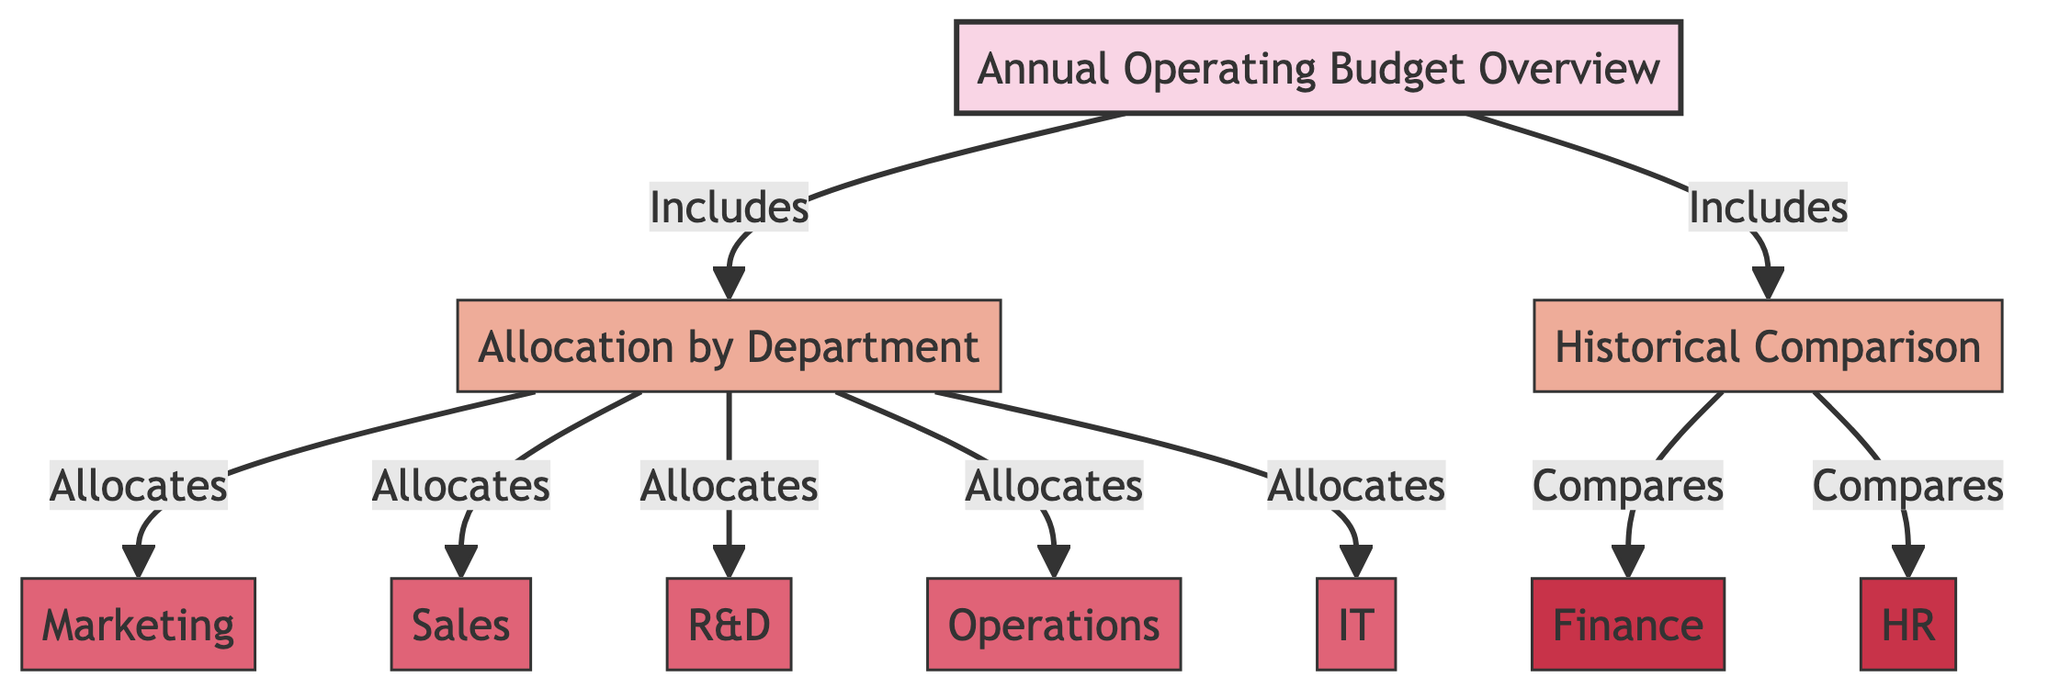What does the "Annual Operating Budget Overview" include? The diagram indicates that the "Annual Operating Budget Overview" includes two main components: "Allocation by Department" and "Historical Comparison." This information is directly connected to the central node, showing the inclusivity of these two categories.
Answer: Allocation by Department, Historical Comparison How many departments are allocated within the "Allocation by Department"? The diagram identifies five departments that receive allocations, which are "Marketing," "Sales," "R&D," "Operations," and "IT." Each department is represented as a separate node branching from the "Allocation by Department" node.
Answer: Five Which comparison is associated with "Finance"? The node "Finance Comparison" is explicitly linked to the "Historical Comparison" section of the diagram, indicating that it is the comparison related to finance.
Answer: Finance What is the relationship between "Historical Comparison" and "HR"? The diagram shows that "HR Comparison" is directly connected to the "Historical Comparison," illustrating a comparative relationship. This signifies that HR performance is assessed in regard to historical data.
Answer: Compares Which category does "Operations" belong to? The node "Operations" is part of the "Allocation by Department" section, indicating that it falls under the category of departmental allocations in the budget overview.
Answer: Allocation by Department How many comparisons are indicated within the "Historical Comparison"? The diagram illustrates that there are two comparisons connected to the "Historical Comparison," specifically "Finance Comparison" and "HR Comparison." This indicates a dual focus in the historical assessment.
Answer: Two What are the main categories represented in the diagram? The main categories shown in the diagram are "Allocation by Department" and "Historical Comparison." These categories categorize how the annual operating budget is organized and assessed.
Answer: Allocation by Department, Historical Comparison Which department does "R&D" represent? The node "R&D" specifically denotes the Research and Development department's allocation within the overall annual operating budget as per the structure of the diagram.
Answer: Research and Development What is the color used for department nodes? In the diagram, the color used for department nodes is a shade of pink, specifically defined as fill color #e06377. This aesthetic choice visually differentiates department nodes from others.
Answer: Pink 